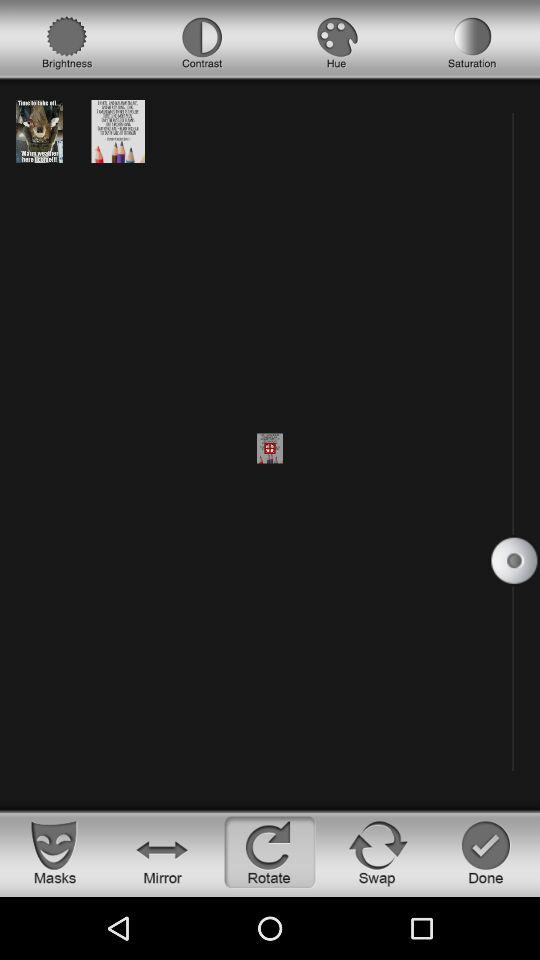Which tab is selected? The selected tab is "Rotate". 